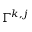<formula> <loc_0><loc_0><loc_500><loc_500>\Gamma ^ { k , j }</formula> 